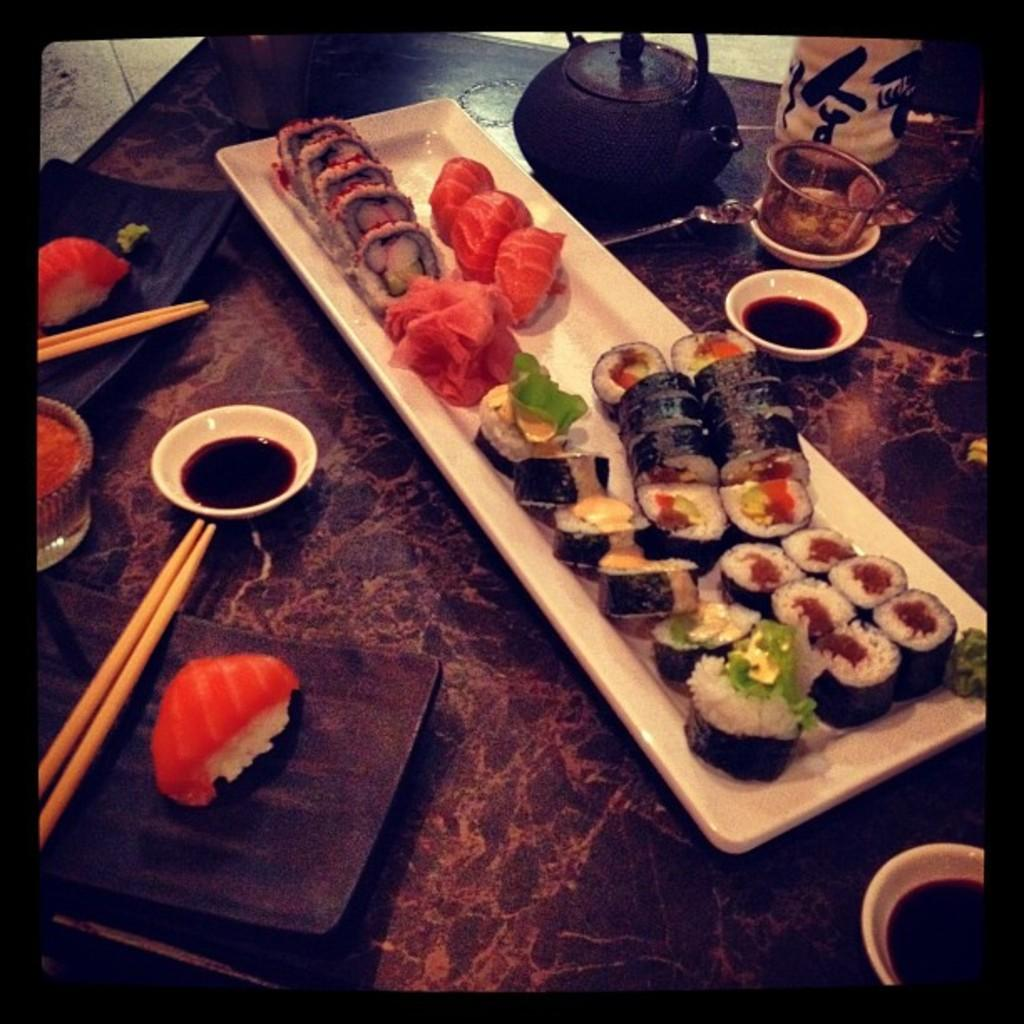What is the main subject of the image? The main subject of the image is food served on a table. What type of container is present in the image? There is a teapot in the image. How is the sauce being stored or served in the image? The sauce is in cups in the image. What reason does the hen have for being in the image? There is no hen present in the image. 